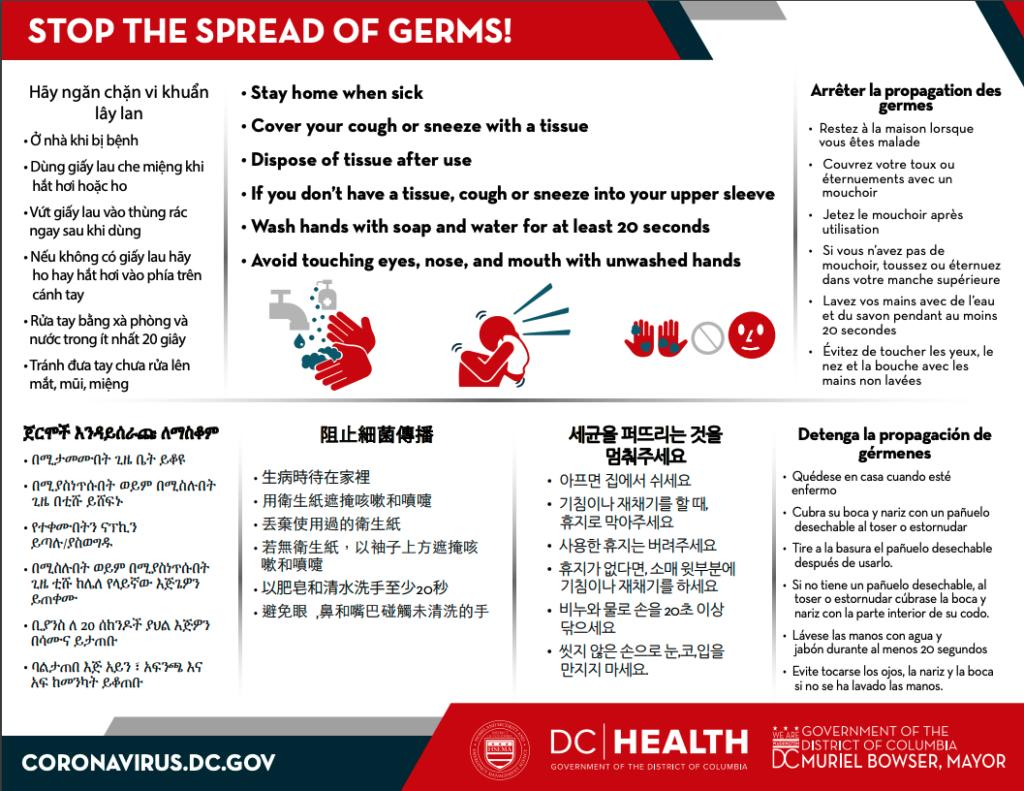Mention a couple of crucial points in this snapshot. In the second image, it appears that the person is holding a tissue. Six instructions are mentioned in English. It is imperative to dispose of tissue after use in order to maintain hygiene and prevent the spread of illness. It is recommended not to touch the parts of your face with unclean hands, which include the eyes, nose, and mouth. The fourth instruction in English is to cough or sneeze into one's upper sleeve if one does not have a tissue. 